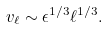Convert formula to latex. <formula><loc_0><loc_0><loc_500><loc_500>v _ { \ell } \sim \epsilon ^ { 1 / 3 } \ell ^ { 1 / 3 } .</formula> 